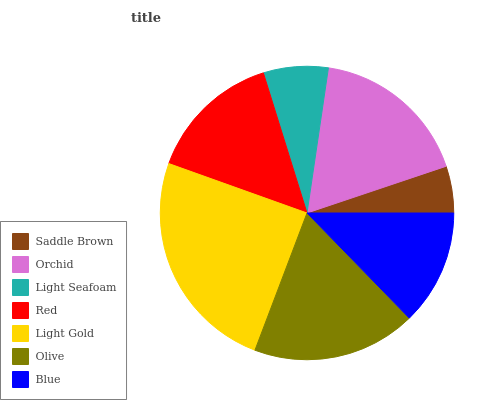Is Saddle Brown the minimum?
Answer yes or no. Yes. Is Light Gold the maximum?
Answer yes or no. Yes. Is Orchid the minimum?
Answer yes or no. No. Is Orchid the maximum?
Answer yes or no. No. Is Orchid greater than Saddle Brown?
Answer yes or no. Yes. Is Saddle Brown less than Orchid?
Answer yes or no. Yes. Is Saddle Brown greater than Orchid?
Answer yes or no. No. Is Orchid less than Saddle Brown?
Answer yes or no. No. Is Red the high median?
Answer yes or no. Yes. Is Red the low median?
Answer yes or no. Yes. Is Orchid the high median?
Answer yes or no. No. Is Olive the low median?
Answer yes or no. No. 